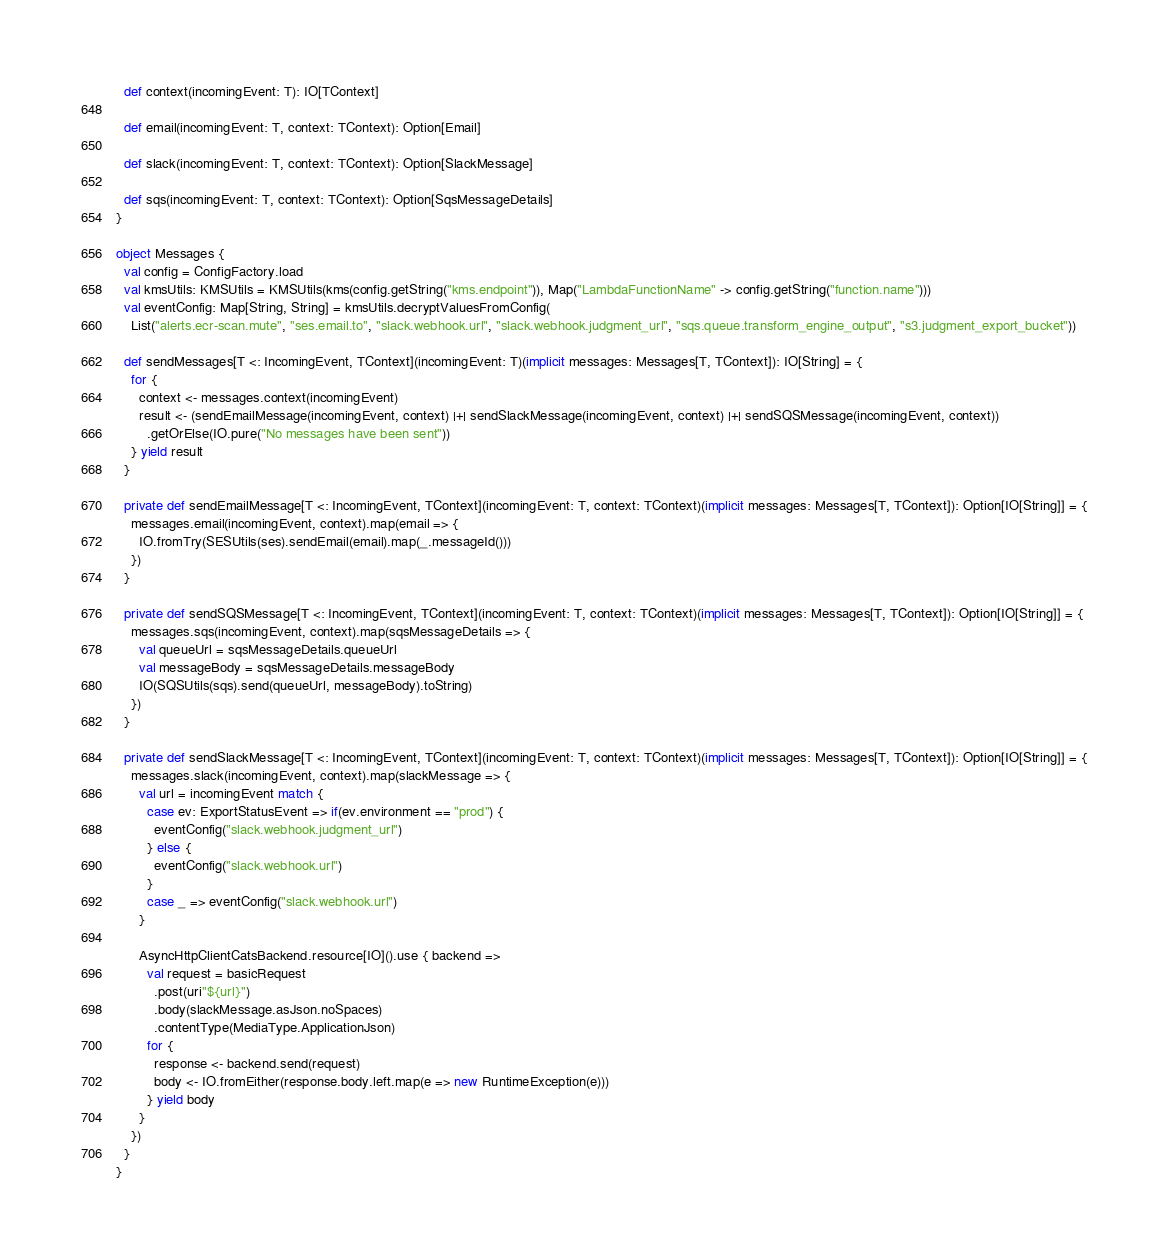Convert code to text. <code><loc_0><loc_0><loc_500><loc_500><_Scala_>  def context(incomingEvent: T): IO[TContext]

  def email(incomingEvent: T, context: TContext): Option[Email]

  def slack(incomingEvent: T, context: TContext): Option[SlackMessage]

  def sqs(incomingEvent: T, context: TContext): Option[SqsMessageDetails]
}

object Messages {
  val config = ConfigFactory.load
  val kmsUtils: KMSUtils = KMSUtils(kms(config.getString("kms.endpoint")), Map("LambdaFunctionName" -> config.getString("function.name")))
  val eventConfig: Map[String, String] = kmsUtils.decryptValuesFromConfig(
    List("alerts.ecr-scan.mute", "ses.email.to", "slack.webhook.url", "slack.webhook.judgment_url", "sqs.queue.transform_engine_output", "s3.judgment_export_bucket"))

  def sendMessages[T <: IncomingEvent, TContext](incomingEvent: T)(implicit messages: Messages[T, TContext]): IO[String] = {
    for {
      context <- messages.context(incomingEvent)
      result <- (sendEmailMessage(incomingEvent, context) |+| sendSlackMessage(incomingEvent, context) |+| sendSQSMessage(incomingEvent, context))
        .getOrElse(IO.pure("No messages have been sent"))
    } yield result
  }

  private def sendEmailMessage[T <: IncomingEvent, TContext](incomingEvent: T, context: TContext)(implicit messages: Messages[T, TContext]): Option[IO[String]] = {
    messages.email(incomingEvent, context).map(email => {
      IO.fromTry(SESUtils(ses).sendEmail(email).map(_.messageId()))
    })
  }

  private def sendSQSMessage[T <: IncomingEvent, TContext](incomingEvent: T, context: TContext)(implicit messages: Messages[T, TContext]): Option[IO[String]] = {
    messages.sqs(incomingEvent, context).map(sqsMessageDetails => {
      val queueUrl = sqsMessageDetails.queueUrl
      val messageBody = sqsMessageDetails.messageBody
      IO(SQSUtils(sqs).send(queueUrl, messageBody).toString)
    })
  }

  private def sendSlackMessage[T <: IncomingEvent, TContext](incomingEvent: T, context: TContext)(implicit messages: Messages[T, TContext]): Option[IO[String]] = {
    messages.slack(incomingEvent, context).map(slackMessage => {
      val url = incomingEvent match {
        case ev: ExportStatusEvent => if(ev.environment == "prod") {
          eventConfig("slack.webhook.judgment_url")
        } else {
          eventConfig("slack.webhook.url")
        }
        case _ => eventConfig("slack.webhook.url")
      }

      AsyncHttpClientCatsBackend.resource[IO]().use { backend =>
        val request = basicRequest
          .post(uri"${url}")
          .body(slackMessage.asJson.noSpaces)
          .contentType(MediaType.ApplicationJson)
        for {
          response <- backend.send(request)
          body <- IO.fromEither(response.body.left.map(e => new RuntimeException(e)))
        } yield body
      }
    })
  }
}
</code> 